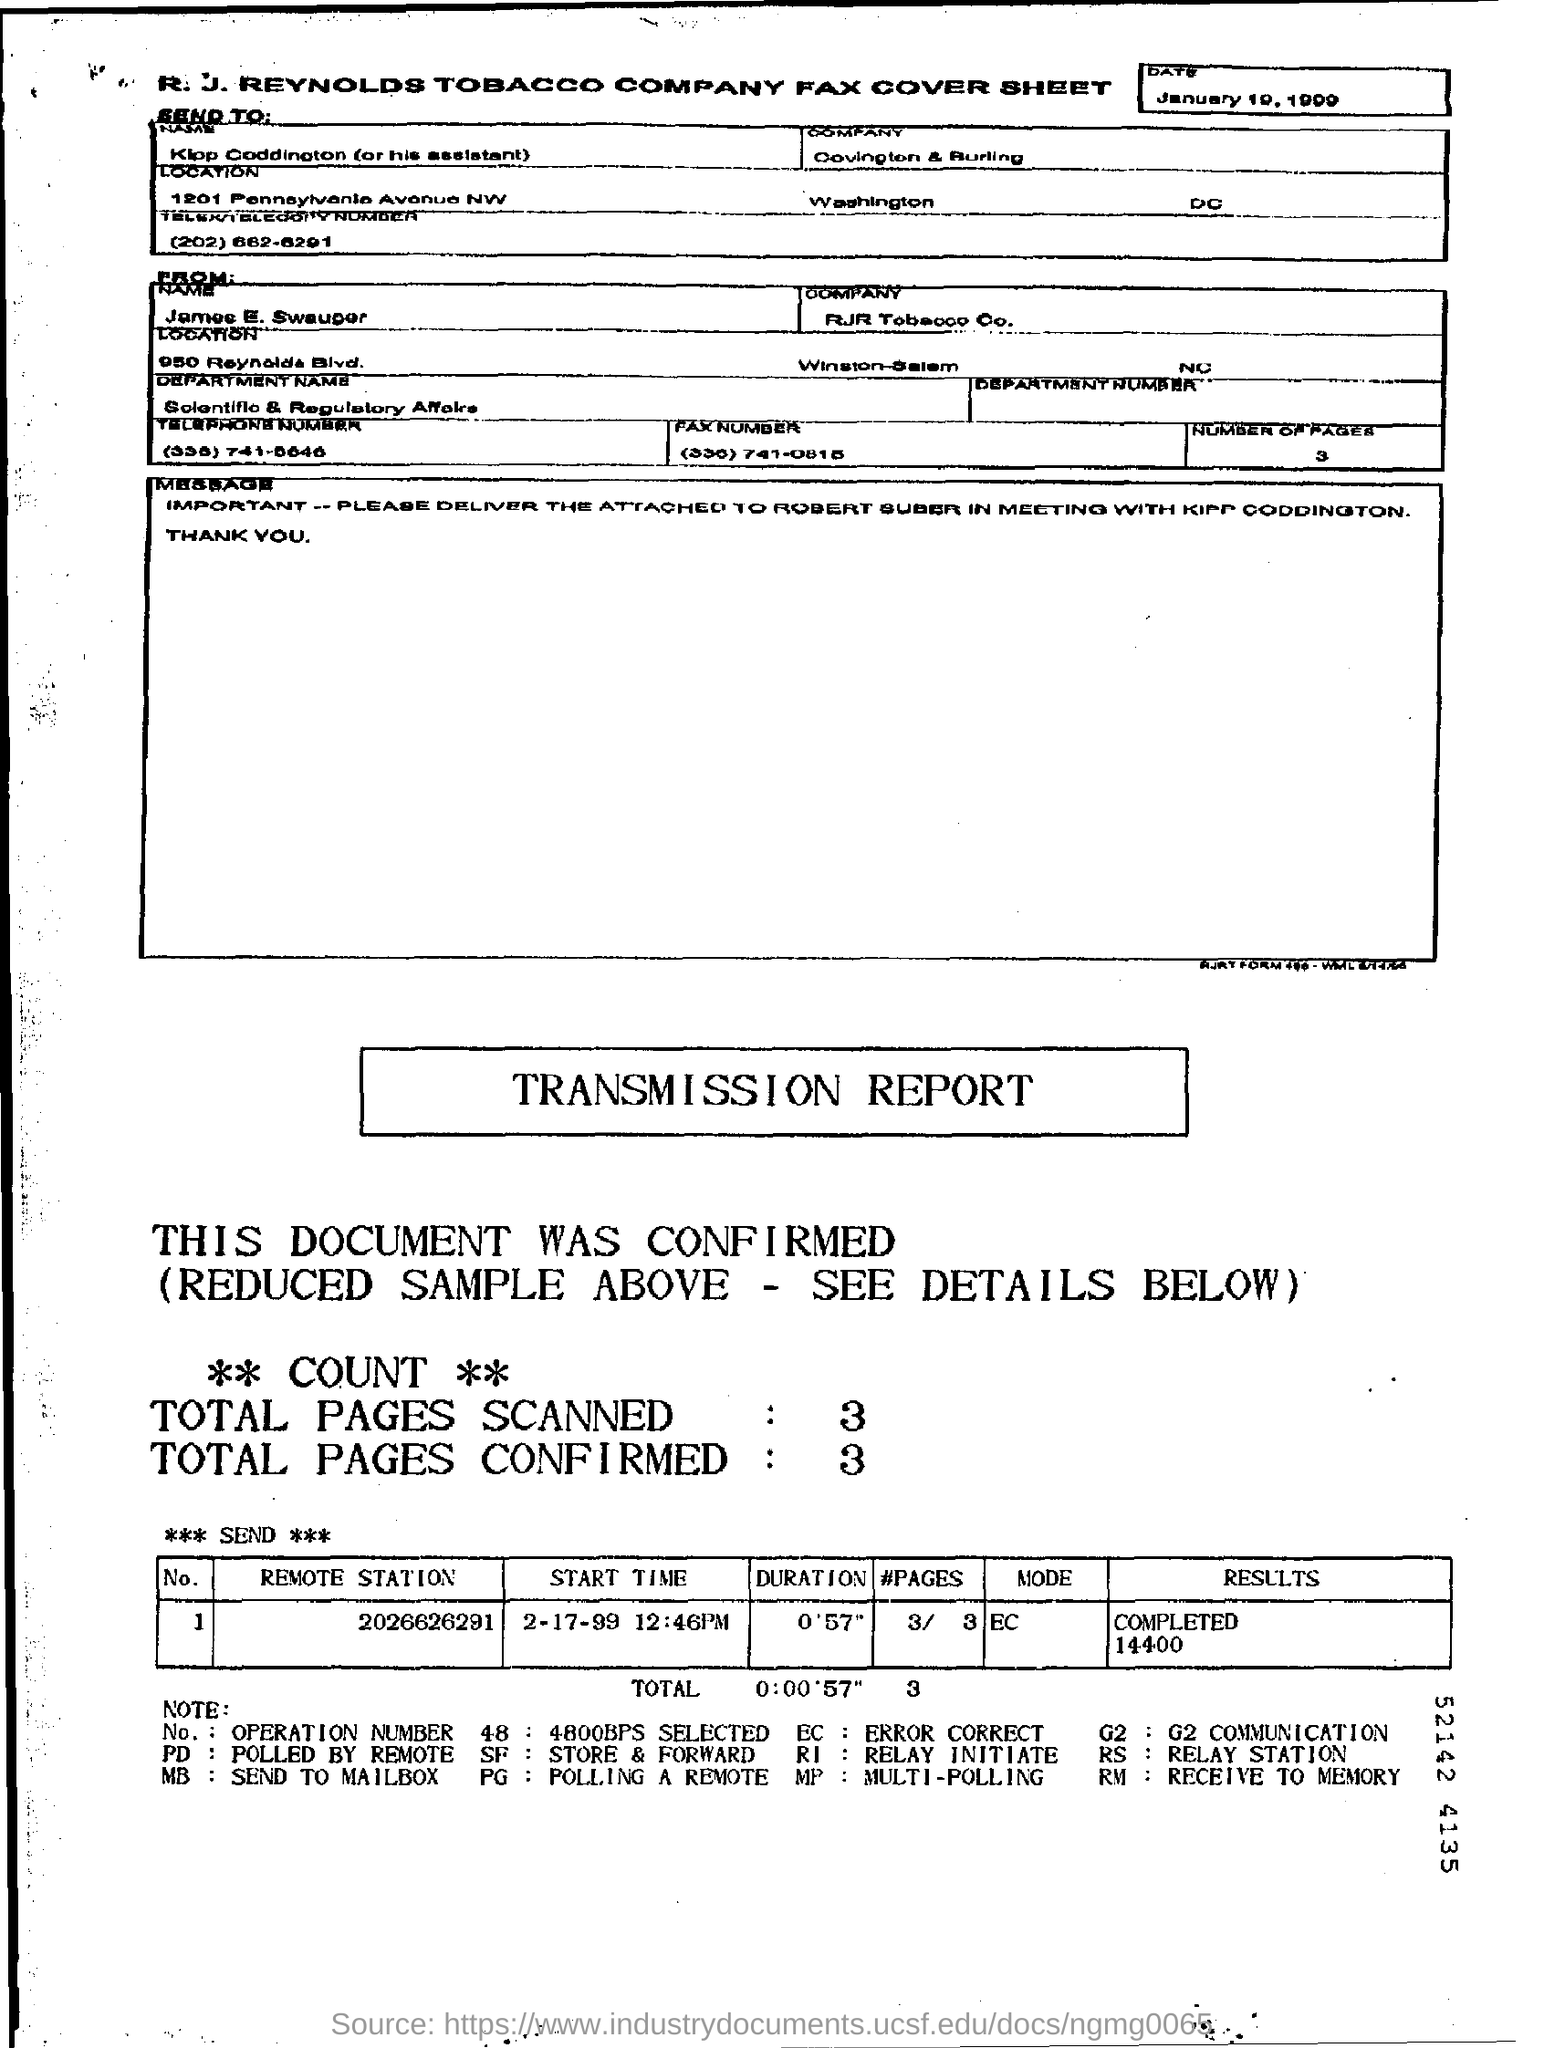To Whom is this Fax addressed to?
Make the answer very short. Klop Coddington (or his assistant). To Which Company is this Fax addressed to?
Your response must be concise. Covington & Burling. What are the Total Pages Scanned?
Offer a very short reply. 3. What are the Total Pages Confirmed?
Offer a very short reply. 3. What is the "Start Time" for "Remote Station" "2026626291"?
Make the answer very short. 2-17-99 12:46PM. What is the "Duration" for "Remote Station" "2026626291"?
Your answer should be compact. 0'57". 